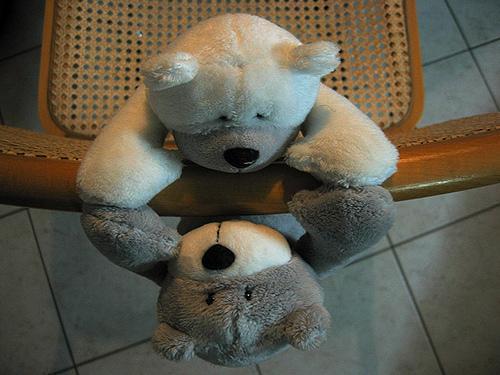How many teddy bears are in the photo?
Give a very brief answer. 2. 